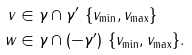<formula> <loc_0><loc_0><loc_500><loc_500>v & \in \gamma \cap \gamma ^ { \prime } \ \{ v _ { \min } , v _ { \max } \} \\ w & \in \gamma \cap ( - \gamma ^ { \prime } ) \ \{ v _ { \min } , v _ { \max } \} . \\</formula> 